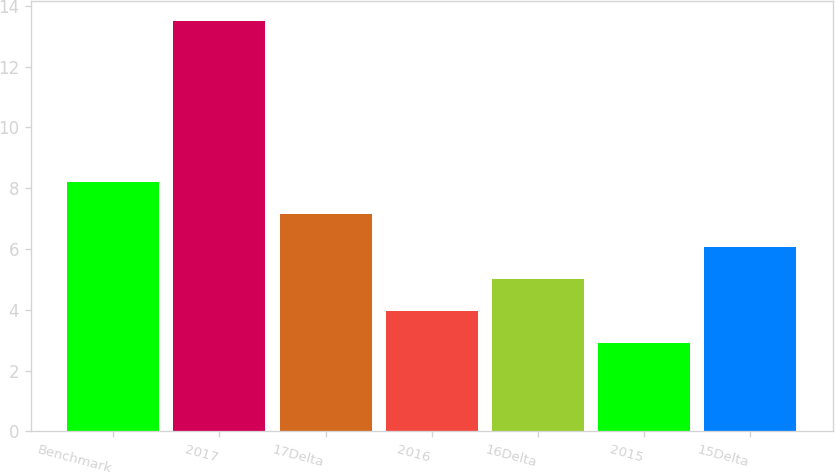<chart> <loc_0><loc_0><loc_500><loc_500><bar_chart><fcel>Benchmark<fcel>2017<fcel>17Delta<fcel>2016<fcel>16Delta<fcel>2015<fcel>15Delta<nl><fcel>8.2<fcel>13.5<fcel>7.14<fcel>3.96<fcel>5.02<fcel>2.9<fcel>6.08<nl></chart> 